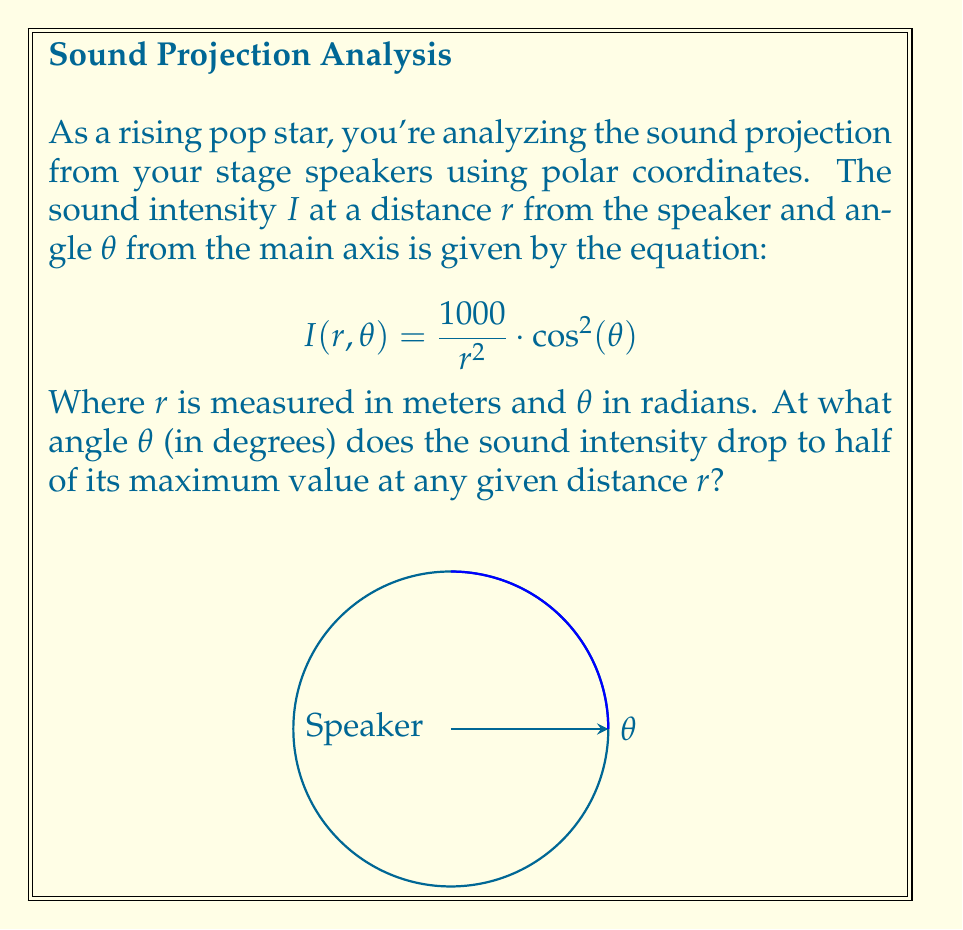What is the answer to this math problem? Let's approach this step-by-step:

1) The maximum intensity occurs when $\cos^2(\theta)$ is at its maximum, which is 1. This happens when $\theta = 0$.

2) We want to find the angle where the intensity is half of this maximum. Let's call this angle $\theta_{half}$.

3) At any given $r$, the intensity at $\theta_{half}$ should be half of the intensity at $\theta = 0$:

   $$\frac{1000}{r^2} \cdot \cos^2(\theta_{half}) = \frac{1}{2} \cdot \frac{1000}{r^2} \cdot 1$$

4) The $\frac{1000}{r^2}$ cancels out on both sides:

   $$\cos^2(\theta_{half}) = \frac{1}{2}$$

5) Taking the square root of both sides:

   $$|\cos(\theta_{half})| = \frac{1}{\sqrt{2}}$$

6) Since we're dealing with the first quadrant (sound projection), we can drop the absolute value signs:

   $$\cos(\theta_{half}) = \frac{1}{\sqrt{2}}$$

7) Taking the inverse cosine (arccos) of both sides:

   $$\theta_{half} = \arccos(\frac{1}{\sqrt{2}})$$

8) This gives us the angle in radians. To convert to degrees, we multiply by $\frac{180}{\pi}$:

   $$\theta_{half} = \arccos(\frac{1}{\sqrt{2}}) \cdot \frac{180}{\pi} \approx 45^\circ$$
Answer: 45° 